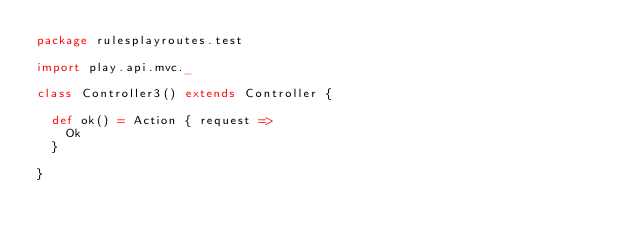<code> <loc_0><loc_0><loc_500><loc_500><_Scala_>package rulesplayroutes.test

import play.api.mvc._

class Controller3() extends Controller {

  def ok() = Action { request =>
    Ok
  }

}</code> 